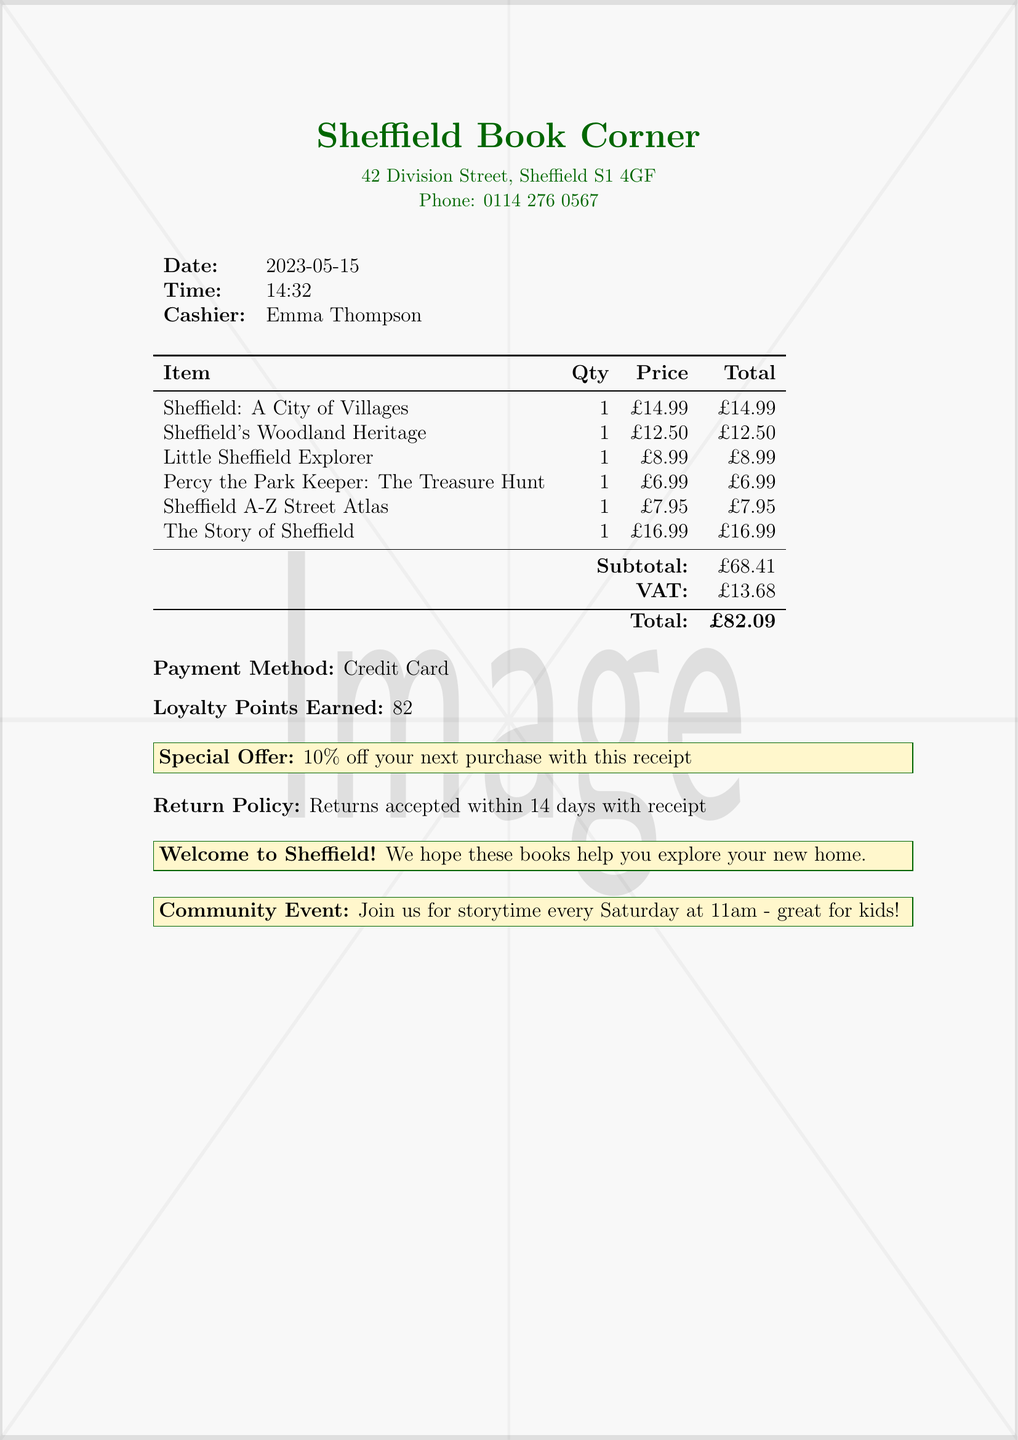What is the name of the bookshop? The document clearly states the name of the bookshop at the top.
Answer: Sheffield Book Corner What is the address of the bookshop? The address is provided just below the name of the bookshop.
Answer: 42 Division Street, Sheffield S1 4GF What is the date of the purchase? The date is specified in the receipt section detailing the transaction.
Answer: 2023-05-15 Who is the cashier? The name of the cashier is mentioned in the receipt details.
Answer: Emma Thompson What is the total amount paid? The total amount is calculated and presented at the bottom of the receipt.
Answer: £82.09 How many loyalty points were earned? The number of loyalty points earned is stated directly in the receipt.
Answer: 82 What percentage off the next purchase is offered? The special offer section includes the percentage discount for the next purchase.
Answer: 10% When does the community event take place? The timing of the community event is mentioned in the relevant section of the receipt.
Answer: Every Saturday at 11am What book is authored by Peter Machan? The item lists include the books along with their respective authors.
Answer: Sheffield: A City of Villages 